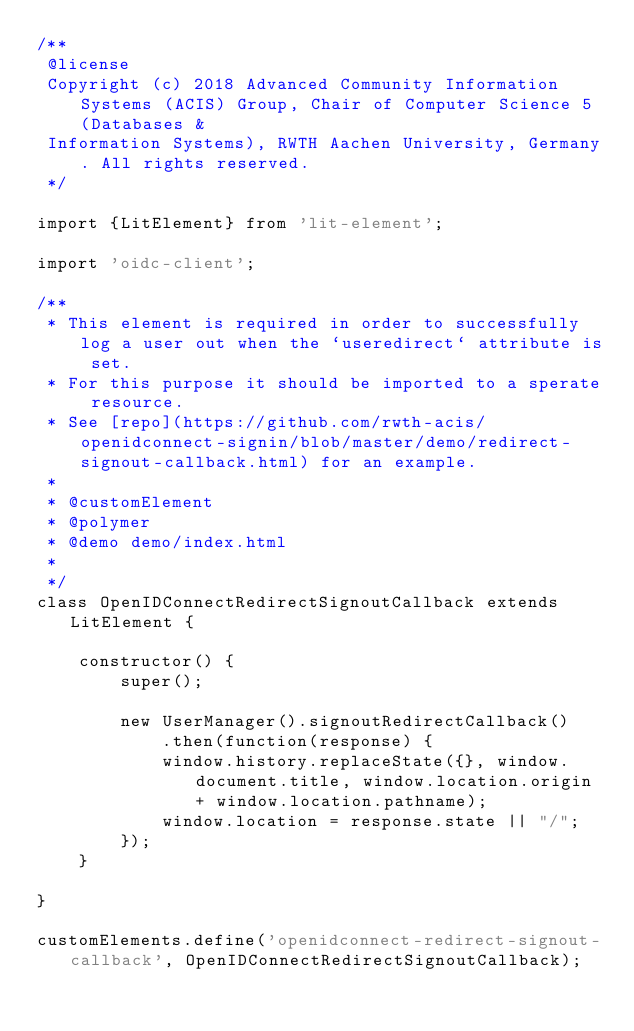Convert code to text. <code><loc_0><loc_0><loc_500><loc_500><_JavaScript_>/**
 @license
 Copyright (c) 2018 Advanced Community Information Systems (ACIS) Group, Chair of Computer Science 5 (Databases &
 Information Systems), RWTH Aachen University, Germany. All rights reserved.
 */

import {LitElement} from 'lit-element';

import 'oidc-client';

/**
 * This element is required in order to successfully log a user out when the `useredirect` attribute is set.
 * For this purpose it should be imported to a sperate resource.
 * See [repo](https://github.com/rwth-acis/openidconnect-signin/blob/master/demo/redirect-signout-callback.html) for an example.
 *
 * @customElement
 * @polymer
 * @demo demo/index.html
 *
 */
class OpenIDConnectRedirectSignoutCallback extends LitElement {

    constructor() {
        super();

        new UserManager().signoutRedirectCallback()
            .then(function(response) {
            window.history.replaceState({}, window.document.title, window.location.origin + window.location.pathname);
            window.location = response.state || "/";
        });
    }

}

customElements.define('openidconnect-redirect-signout-callback', OpenIDConnectRedirectSignoutCallback);
</code> 